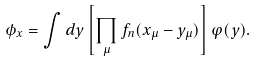<formula> <loc_0><loc_0><loc_500><loc_500>\phi _ { x } = \int d y \left [ \prod _ { \mu } f _ { n } ( x _ { \mu } - y _ { \mu } ) \right ] \varphi ( y ) .</formula> 